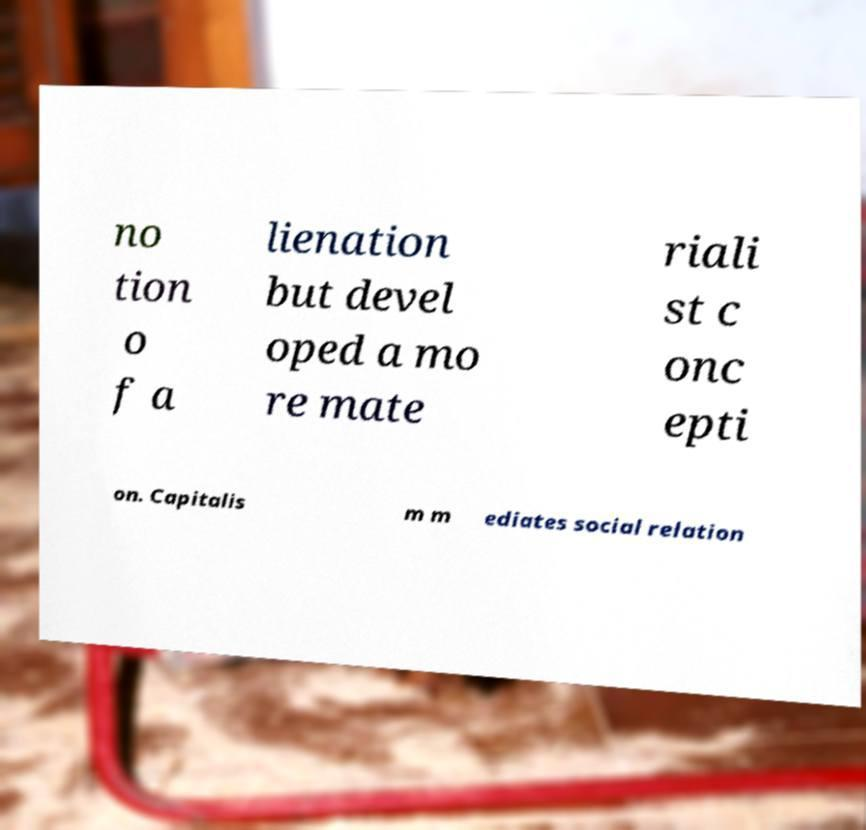Please identify and transcribe the text found in this image. no tion o f a lienation but devel oped a mo re mate riali st c onc epti on. Capitalis m m ediates social relation 